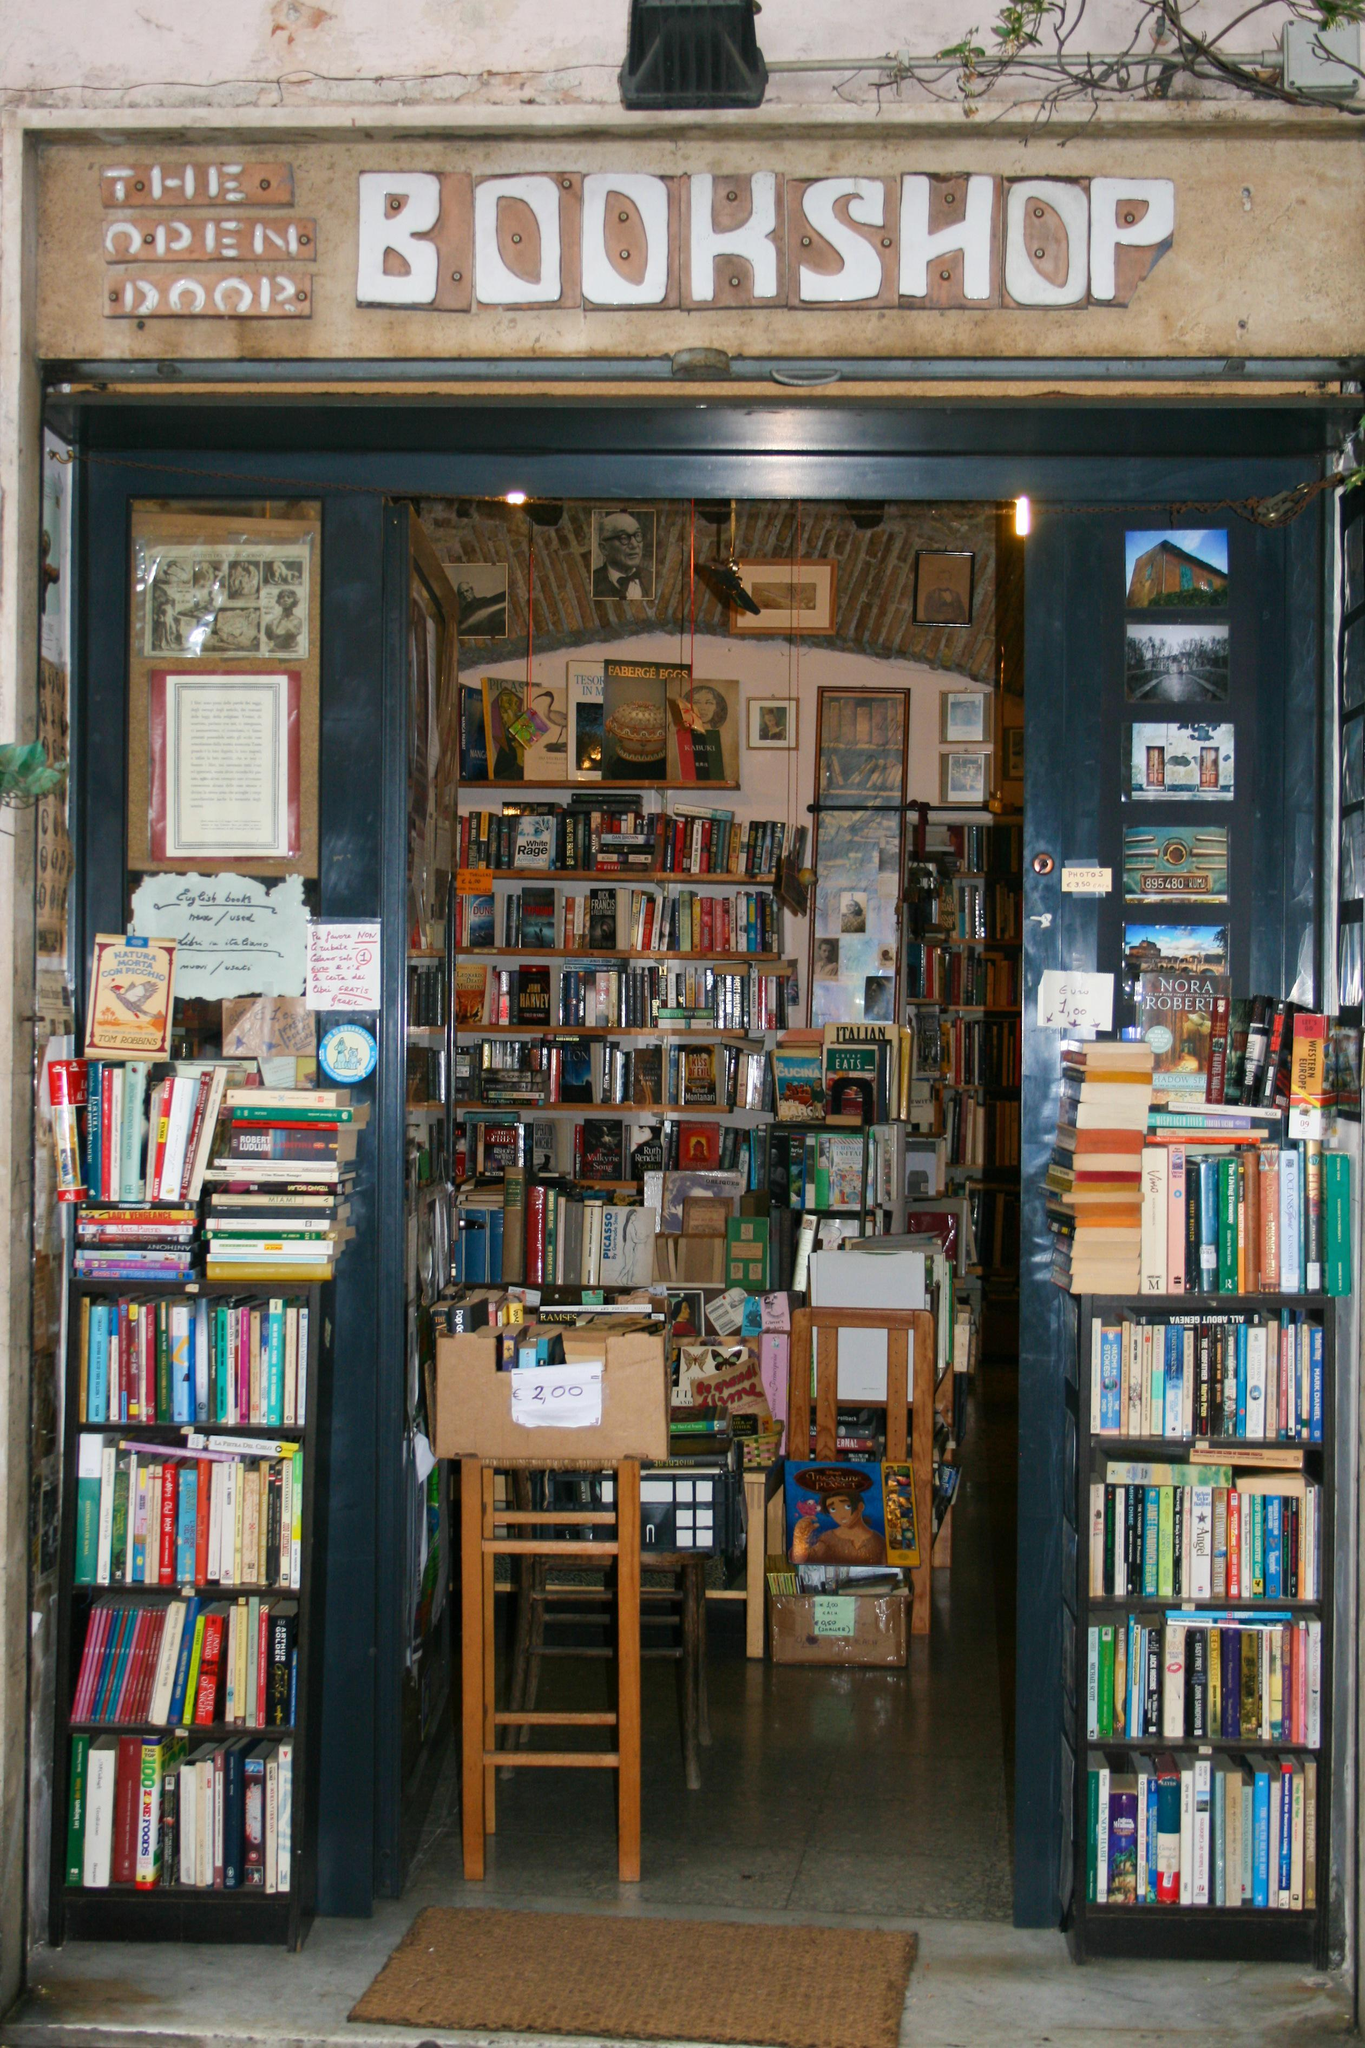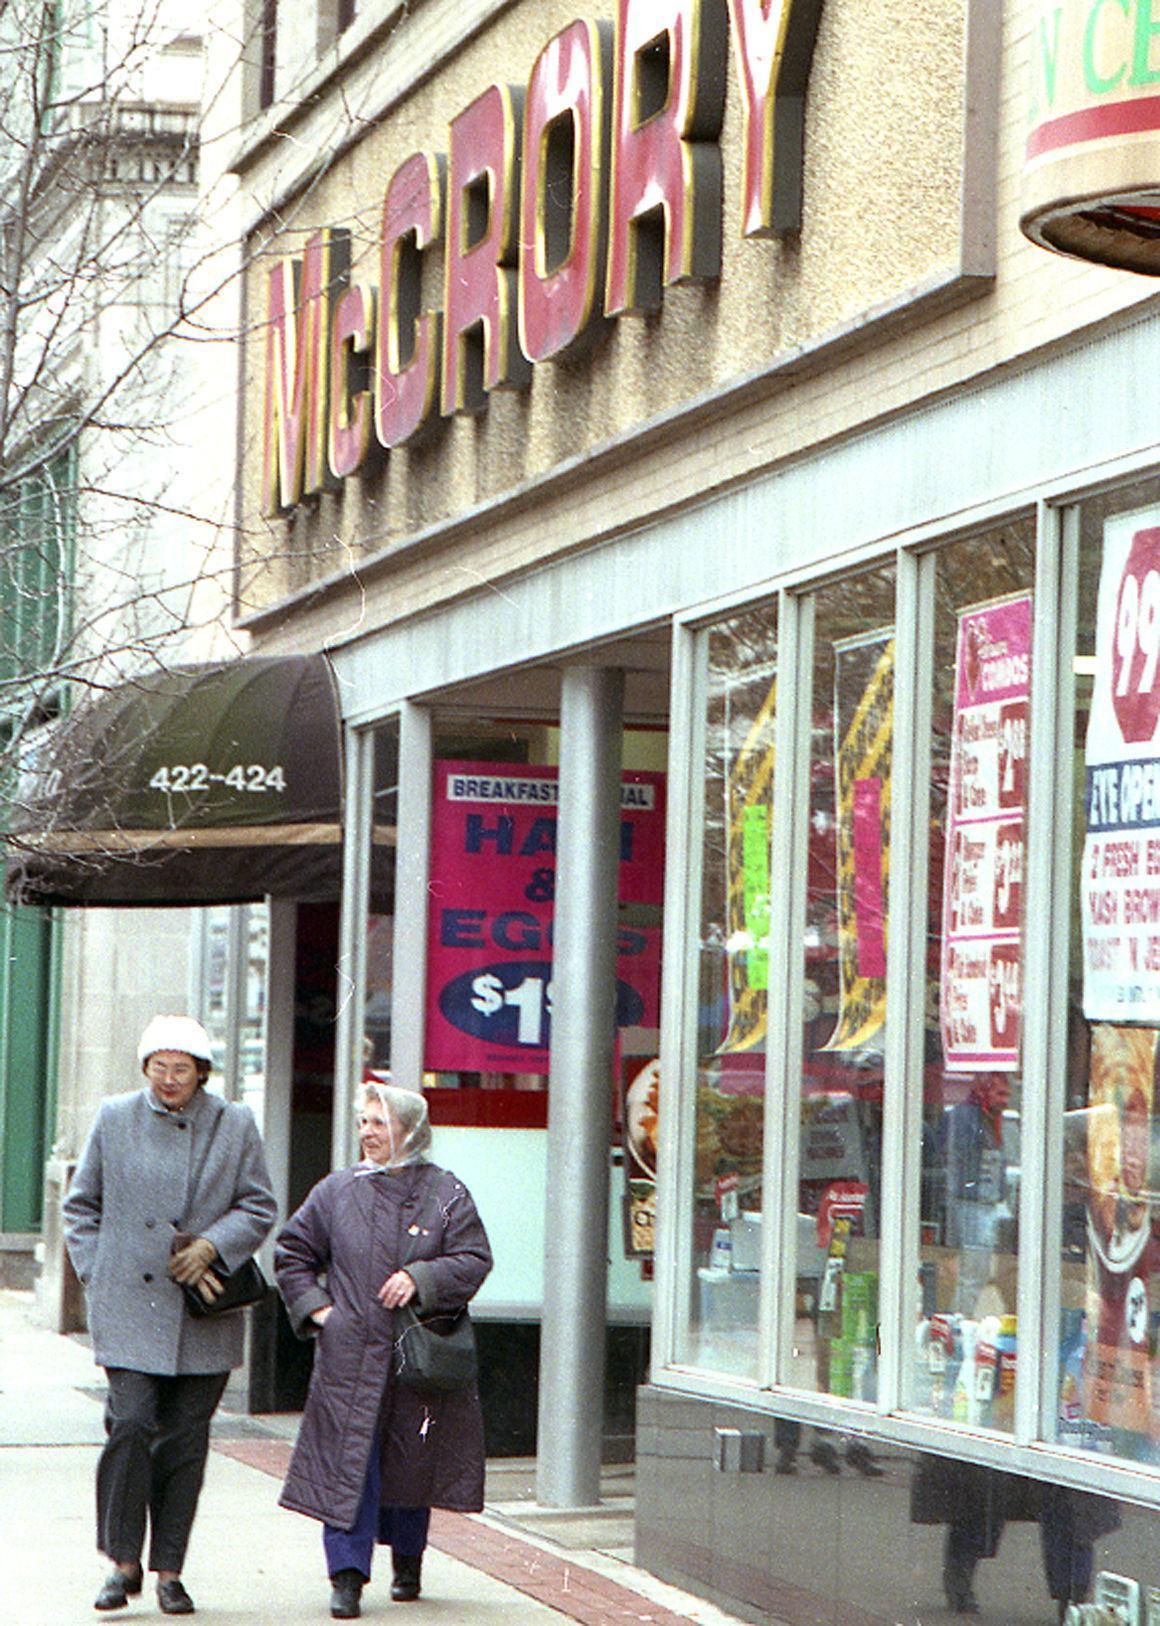The first image is the image on the left, the second image is the image on the right. Considering the images on both sides, is "An image shows at least two people walking past a shop." valid? Answer yes or no. Yes. 